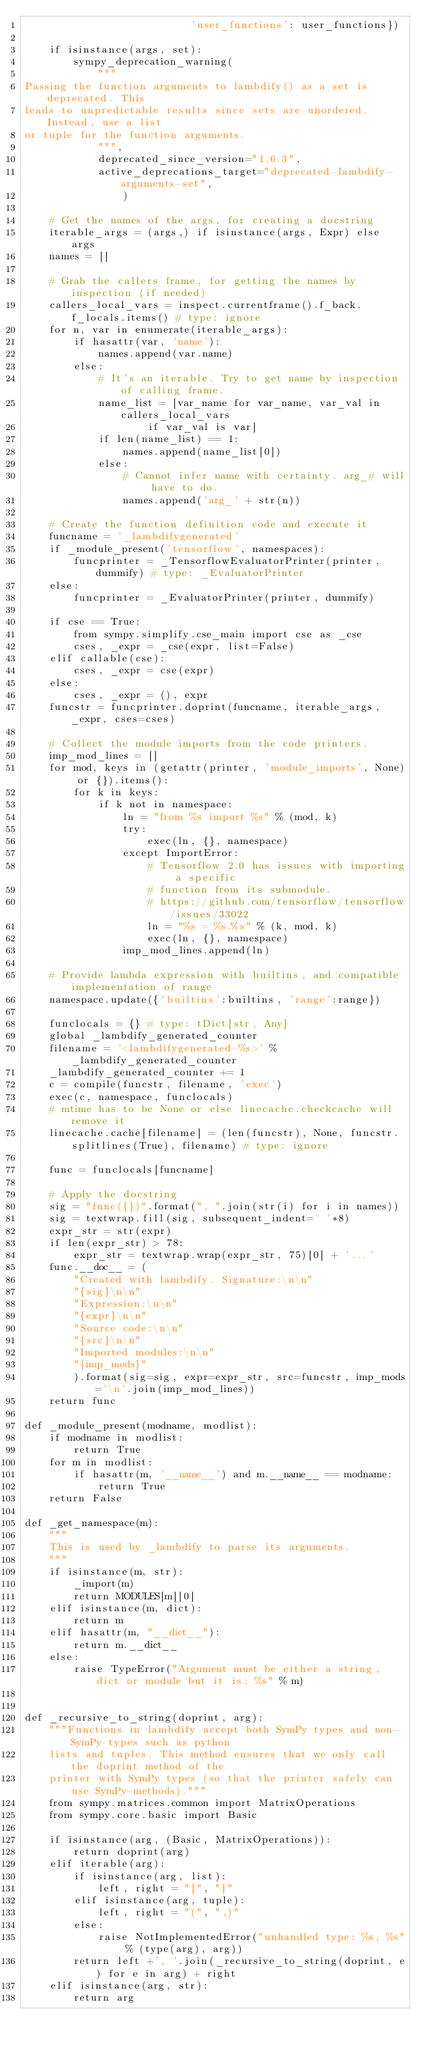Convert code to text. <code><loc_0><loc_0><loc_500><loc_500><_Python_>                           'user_functions': user_functions})

    if isinstance(args, set):
        sympy_deprecation_warning(
            """
Passing the function arguments to lambdify() as a set is deprecated. This
leads to unpredictable results since sets are unordered. Instead, use a list
or tuple for the function arguments.
            """,
            deprecated_since_version="1.6.3",
            active_deprecations_target="deprecated-lambdify-arguments-set",
                )

    # Get the names of the args, for creating a docstring
    iterable_args = (args,) if isinstance(args, Expr) else args
    names = []

    # Grab the callers frame, for getting the names by inspection (if needed)
    callers_local_vars = inspect.currentframe().f_back.f_locals.items() # type: ignore
    for n, var in enumerate(iterable_args):
        if hasattr(var, 'name'):
            names.append(var.name)
        else:
            # It's an iterable. Try to get name by inspection of calling frame.
            name_list = [var_name for var_name, var_val in callers_local_vars
                    if var_val is var]
            if len(name_list) == 1:
                names.append(name_list[0])
            else:
                # Cannot infer name with certainty. arg_# will have to do.
                names.append('arg_' + str(n))

    # Create the function definition code and execute it
    funcname = '_lambdifygenerated'
    if _module_present('tensorflow', namespaces):
        funcprinter = _TensorflowEvaluatorPrinter(printer, dummify) # type: _EvaluatorPrinter
    else:
        funcprinter = _EvaluatorPrinter(printer, dummify)

    if cse == True:
        from sympy.simplify.cse_main import cse as _cse
        cses, _expr = _cse(expr, list=False)
    elif callable(cse):
        cses, _expr = cse(expr)
    else:
        cses, _expr = (), expr
    funcstr = funcprinter.doprint(funcname, iterable_args, _expr, cses=cses)

    # Collect the module imports from the code printers.
    imp_mod_lines = []
    for mod, keys in (getattr(printer, 'module_imports', None) or {}).items():
        for k in keys:
            if k not in namespace:
                ln = "from %s import %s" % (mod, k)
                try:
                    exec(ln, {}, namespace)
                except ImportError:
                    # Tensorflow 2.0 has issues with importing a specific
                    # function from its submodule.
                    # https://github.com/tensorflow/tensorflow/issues/33022
                    ln = "%s = %s.%s" % (k, mod, k)
                    exec(ln, {}, namespace)
                imp_mod_lines.append(ln)

    # Provide lambda expression with builtins, and compatible implementation of range
    namespace.update({'builtins':builtins, 'range':range})

    funclocals = {} # type: tDict[str, Any]
    global _lambdify_generated_counter
    filename = '<lambdifygenerated-%s>' % _lambdify_generated_counter
    _lambdify_generated_counter += 1
    c = compile(funcstr, filename, 'exec')
    exec(c, namespace, funclocals)
    # mtime has to be None or else linecache.checkcache will remove it
    linecache.cache[filename] = (len(funcstr), None, funcstr.splitlines(True), filename) # type: ignore

    func = funclocals[funcname]

    # Apply the docstring
    sig = "func({})".format(", ".join(str(i) for i in names))
    sig = textwrap.fill(sig, subsequent_indent=' '*8)
    expr_str = str(expr)
    if len(expr_str) > 78:
        expr_str = textwrap.wrap(expr_str, 75)[0] + '...'
    func.__doc__ = (
        "Created with lambdify. Signature:\n\n"
        "{sig}\n\n"
        "Expression:\n\n"
        "{expr}\n\n"
        "Source code:\n\n"
        "{src}\n\n"
        "Imported modules:\n\n"
        "{imp_mods}"
        ).format(sig=sig, expr=expr_str, src=funcstr, imp_mods='\n'.join(imp_mod_lines))
    return func

def _module_present(modname, modlist):
    if modname in modlist:
        return True
    for m in modlist:
        if hasattr(m, '__name__') and m.__name__ == modname:
            return True
    return False

def _get_namespace(m):
    """
    This is used by _lambdify to parse its arguments.
    """
    if isinstance(m, str):
        _import(m)
        return MODULES[m][0]
    elif isinstance(m, dict):
        return m
    elif hasattr(m, "__dict__"):
        return m.__dict__
    else:
        raise TypeError("Argument must be either a string, dict or module but it is: %s" % m)


def _recursive_to_string(doprint, arg):
    """Functions in lambdify accept both SymPy types and non-SymPy types such as python
    lists and tuples. This method ensures that we only call the doprint method of the
    printer with SymPy types (so that the printer safely can use SymPy-methods)."""
    from sympy.matrices.common import MatrixOperations
    from sympy.core.basic import Basic

    if isinstance(arg, (Basic, MatrixOperations)):
        return doprint(arg)
    elif iterable(arg):
        if isinstance(arg, list):
            left, right = "[", "]"
        elif isinstance(arg, tuple):
            left, right = "(", ",)"
        else:
            raise NotImplementedError("unhandled type: %s, %s" % (type(arg), arg))
        return left +', '.join(_recursive_to_string(doprint, e) for e in arg) + right
    elif isinstance(arg, str):
        return arg</code> 